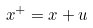<formula> <loc_0><loc_0><loc_500><loc_500>x ^ { + } = x + u</formula> 